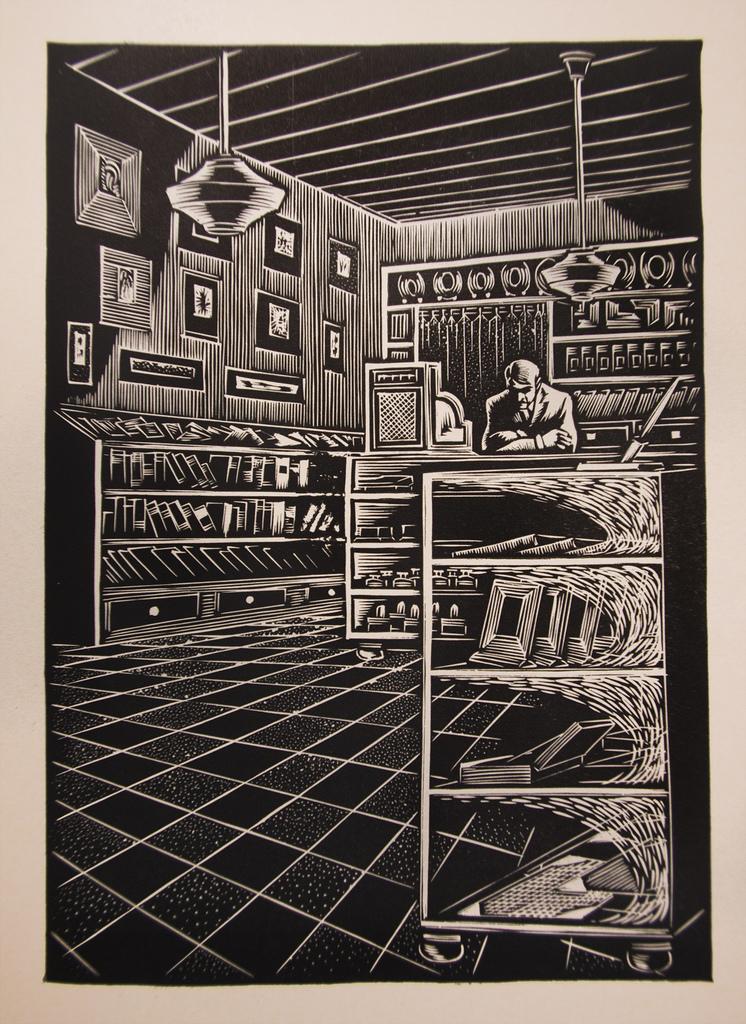How many people are in this photo?
Provide a short and direct response. Answering does not require reading text in the image. 